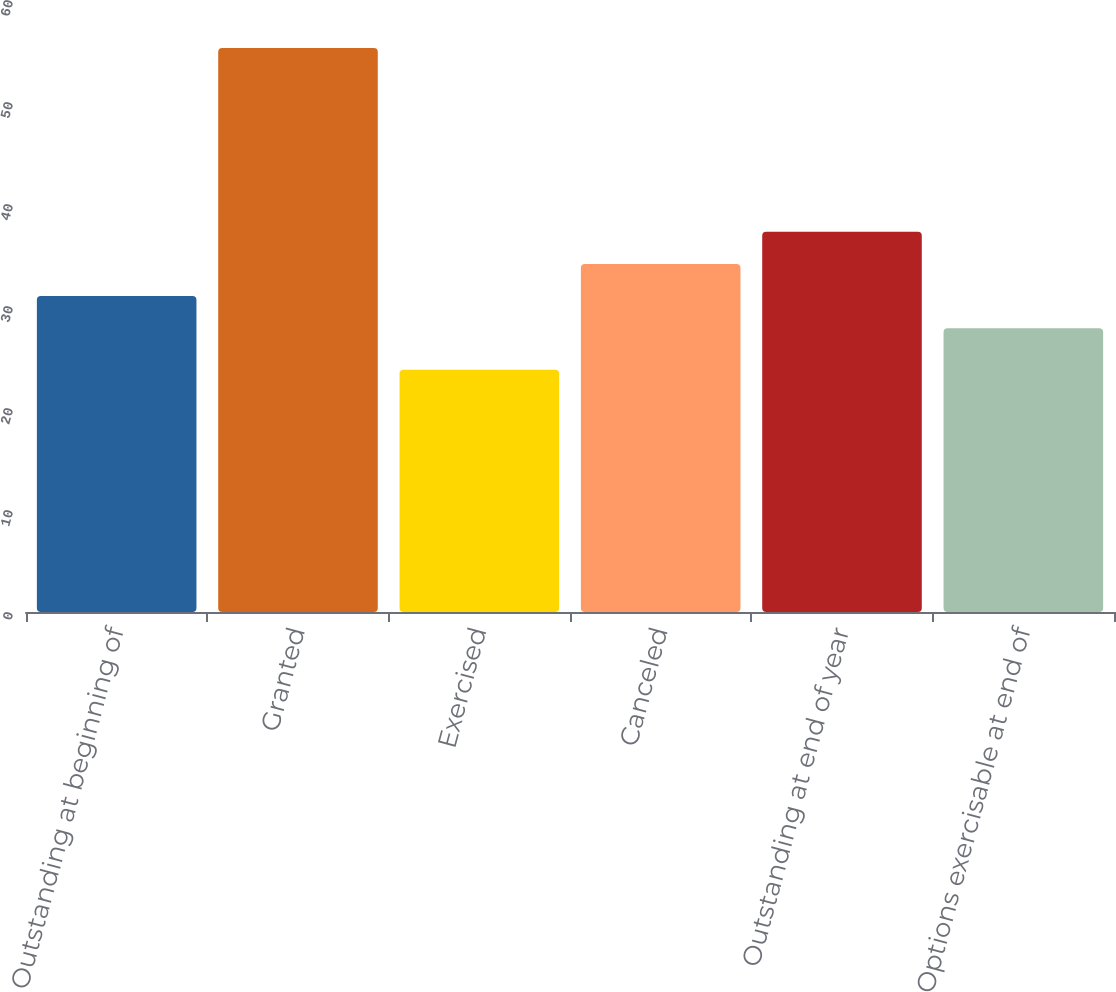Convert chart. <chart><loc_0><loc_0><loc_500><loc_500><bar_chart><fcel>Outstanding at beginning of<fcel>Granted<fcel>Exercised<fcel>Canceled<fcel>Outstanding at end of year<fcel>Options exercisable at end of<nl><fcel>30.97<fcel>55.29<fcel>23.76<fcel>34.12<fcel>37.27<fcel>27.82<nl></chart> 